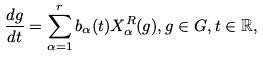Convert formula to latex. <formula><loc_0><loc_0><loc_500><loc_500>\frac { d g } { d t } = \sum _ { \alpha = 1 } ^ { r } b _ { \alpha } ( t ) X _ { \alpha } ^ { R } ( g ) , g \in G , t \in \mathbb { R } ,</formula> 